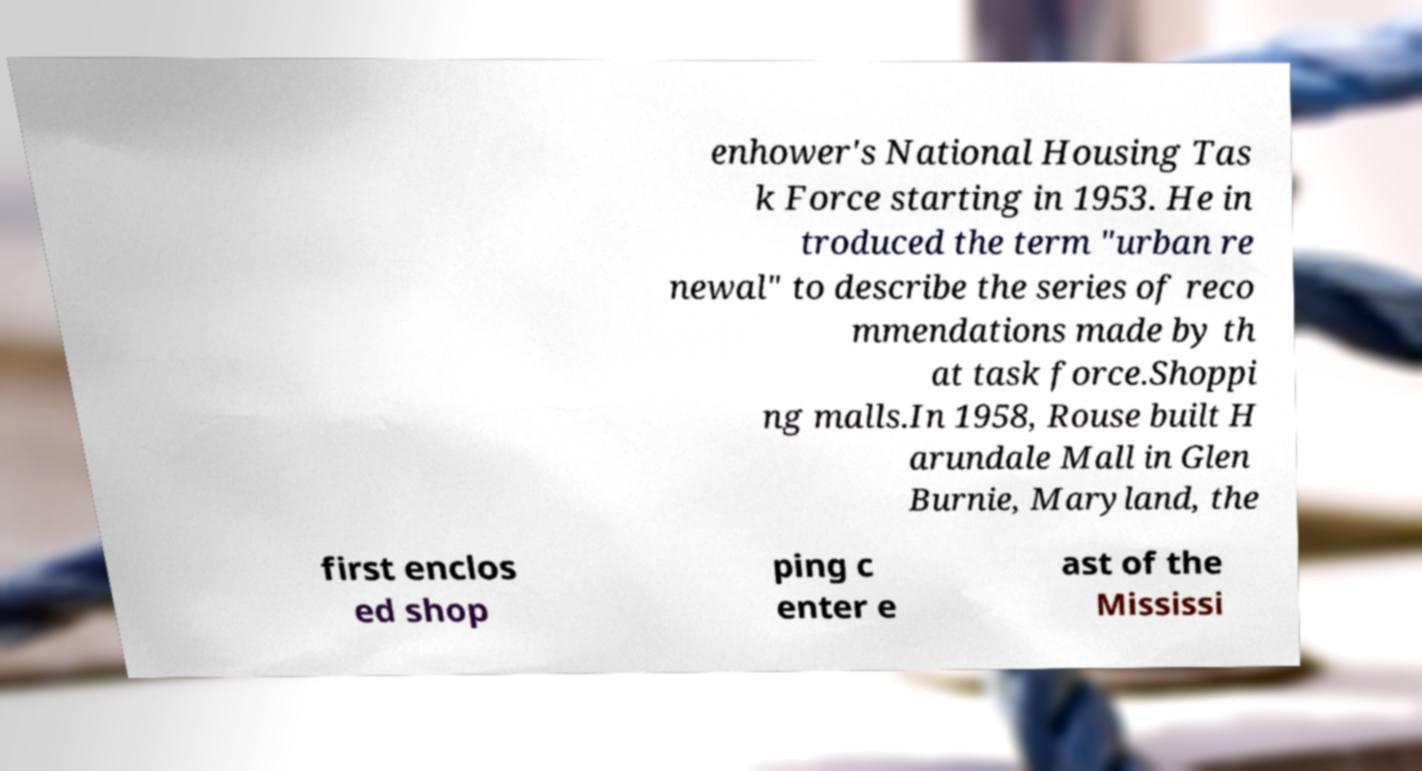Can you read and provide the text displayed in the image?This photo seems to have some interesting text. Can you extract and type it out for me? enhower's National Housing Tas k Force starting in 1953. He in troduced the term "urban re newal" to describe the series of reco mmendations made by th at task force.Shoppi ng malls.In 1958, Rouse built H arundale Mall in Glen Burnie, Maryland, the first enclos ed shop ping c enter e ast of the Mississi 